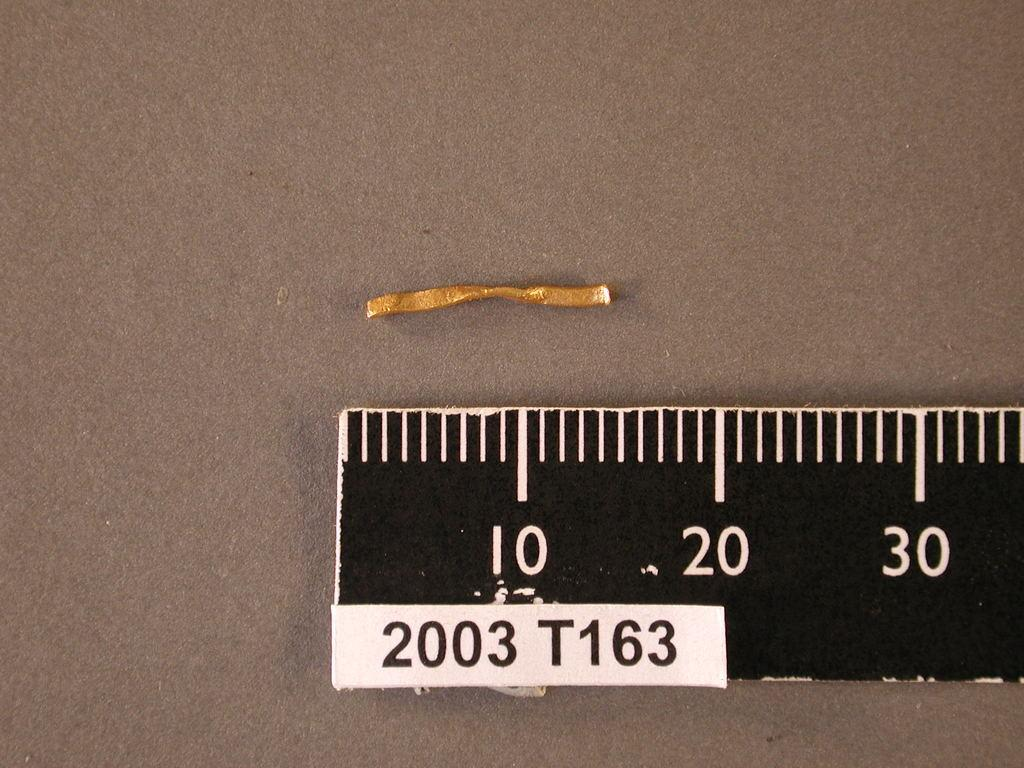Provide a one-sentence caption for the provided image. a small piece of golden string sits in front of a ruler labeled T163. 